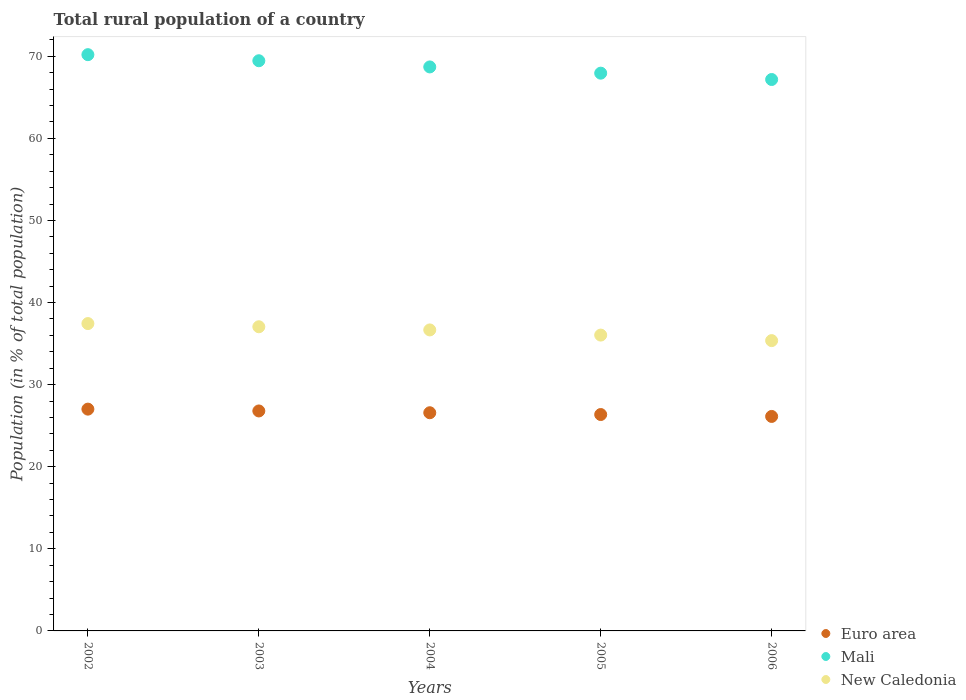Is the number of dotlines equal to the number of legend labels?
Provide a succinct answer. Yes. What is the rural population in New Caledonia in 2002?
Your response must be concise. 37.44. Across all years, what is the maximum rural population in New Caledonia?
Make the answer very short. 37.44. Across all years, what is the minimum rural population in Mali?
Your answer should be very brief. 67.17. What is the total rural population in Mali in the graph?
Offer a terse response. 343.45. What is the difference between the rural population in New Caledonia in 2003 and that in 2006?
Make the answer very short. 1.69. What is the difference between the rural population in Euro area in 2006 and the rural population in New Caledonia in 2004?
Keep it short and to the point. -10.54. What is the average rural population in New Caledonia per year?
Make the answer very short. 36.51. In the year 2005, what is the difference between the rural population in New Caledonia and rural population in Mali?
Your answer should be very brief. -31.91. What is the ratio of the rural population in New Caledonia in 2002 to that in 2004?
Your response must be concise. 1.02. Is the rural population in Mali in 2004 less than that in 2005?
Your answer should be compact. No. Is the difference between the rural population in New Caledonia in 2005 and 2006 greater than the difference between the rural population in Mali in 2005 and 2006?
Provide a succinct answer. No. What is the difference between the highest and the second highest rural population in Euro area?
Make the answer very short. 0.22. What is the difference between the highest and the lowest rural population in Mali?
Offer a terse response. 3.03. In how many years, is the rural population in Mali greater than the average rural population in Mali taken over all years?
Give a very brief answer. 3. Does the rural population in New Caledonia monotonically increase over the years?
Make the answer very short. No. Is the rural population in Mali strictly greater than the rural population in New Caledonia over the years?
Provide a succinct answer. Yes. Is the rural population in New Caledonia strictly less than the rural population in Mali over the years?
Offer a terse response. Yes. How many years are there in the graph?
Keep it short and to the point. 5. What is the difference between two consecutive major ticks on the Y-axis?
Keep it short and to the point. 10. Does the graph contain any zero values?
Give a very brief answer. No. Where does the legend appear in the graph?
Keep it short and to the point. Bottom right. What is the title of the graph?
Your answer should be compact. Total rural population of a country. What is the label or title of the Y-axis?
Give a very brief answer. Population (in % of total population). What is the Population (in % of total population) in Euro area in 2002?
Offer a terse response. 27.02. What is the Population (in % of total population) in Mali in 2002?
Ensure brevity in your answer.  70.19. What is the Population (in % of total population) of New Caledonia in 2002?
Provide a short and direct response. 37.44. What is the Population (in % of total population) of Euro area in 2003?
Your answer should be very brief. 26.79. What is the Population (in % of total population) in Mali in 2003?
Your response must be concise. 69.45. What is the Population (in % of total population) in New Caledonia in 2003?
Provide a succinct answer. 37.05. What is the Population (in % of total population) in Euro area in 2004?
Give a very brief answer. 26.58. What is the Population (in % of total population) of Mali in 2004?
Offer a very short reply. 68.7. What is the Population (in % of total population) in New Caledonia in 2004?
Your answer should be compact. 36.66. What is the Population (in % of total population) in Euro area in 2005?
Provide a succinct answer. 26.36. What is the Population (in % of total population) in Mali in 2005?
Provide a succinct answer. 67.94. What is the Population (in % of total population) in New Caledonia in 2005?
Ensure brevity in your answer.  36.03. What is the Population (in % of total population) of Euro area in 2006?
Your response must be concise. 26.13. What is the Population (in % of total population) in Mali in 2006?
Offer a very short reply. 67.17. What is the Population (in % of total population) in New Caledonia in 2006?
Your answer should be compact. 35.36. Across all years, what is the maximum Population (in % of total population) of Euro area?
Your response must be concise. 27.02. Across all years, what is the maximum Population (in % of total population) in Mali?
Provide a short and direct response. 70.19. Across all years, what is the maximum Population (in % of total population) in New Caledonia?
Offer a terse response. 37.44. Across all years, what is the minimum Population (in % of total population) in Euro area?
Keep it short and to the point. 26.13. Across all years, what is the minimum Population (in % of total population) in Mali?
Provide a succinct answer. 67.17. Across all years, what is the minimum Population (in % of total population) in New Caledonia?
Give a very brief answer. 35.36. What is the total Population (in % of total population) of Euro area in the graph?
Give a very brief answer. 132.87. What is the total Population (in % of total population) of Mali in the graph?
Provide a succinct answer. 343.45. What is the total Population (in % of total population) of New Caledonia in the graph?
Ensure brevity in your answer.  182.55. What is the difference between the Population (in % of total population) of Euro area in 2002 and that in 2003?
Make the answer very short. 0.22. What is the difference between the Population (in % of total population) in Mali in 2002 and that in 2003?
Give a very brief answer. 0.74. What is the difference between the Population (in % of total population) of New Caledonia in 2002 and that in 2003?
Your answer should be very brief. 0.39. What is the difference between the Population (in % of total population) in Euro area in 2002 and that in 2004?
Provide a succinct answer. 0.44. What is the difference between the Population (in % of total population) of Mali in 2002 and that in 2004?
Make the answer very short. 1.49. What is the difference between the Population (in % of total population) of New Caledonia in 2002 and that in 2004?
Offer a terse response. 0.78. What is the difference between the Population (in % of total population) in Euro area in 2002 and that in 2005?
Provide a short and direct response. 0.66. What is the difference between the Population (in % of total population) of Mali in 2002 and that in 2005?
Offer a very short reply. 2.25. What is the difference between the Population (in % of total population) in New Caledonia in 2002 and that in 2005?
Ensure brevity in your answer.  1.4. What is the difference between the Population (in % of total population) of Euro area in 2002 and that in 2006?
Offer a terse response. 0.89. What is the difference between the Population (in % of total population) in Mali in 2002 and that in 2006?
Make the answer very short. 3.03. What is the difference between the Population (in % of total population) in New Caledonia in 2002 and that in 2006?
Make the answer very short. 2.08. What is the difference between the Population (in % of total population) of Euro area in 2003 and that in 2004?
Provide a succinct answer. 0.22. What is the difference between the Population (in % of total population) in Mali in 2003 and that in 2004?
Your answer should be very brief. 0.75. What is the difference between the Population (in % of total population) of New Caledonia in 2003 and that in 2004?
Provide a succinct answer. 0.39. What is the difference between the Population (in % of total population) of Euro area in 2003 and that in 2005?
Provide a succinct answer. 0.44. What is the difference between the Population (in % of total population) of Mali in 2003 and that in 2005?
Make the answer very short. 1.51. What is the difference between the Population (in % of total population) of Euro area in 2003 and that in 2006?
Your answer should be very brief. 0.67. What is the difference between the Population (in % of total population) in Mali in 2003 and that in 2006?
Give a very brief answer. 2.29. What is the difference between the Population (in % of total population) of New Caledonia in 2003 and that in 2006?
Make the answer very short. 1.69. What is the difference between the Population (in % of total population) of Euro area in 2004 and that in 2005?
Your answer should be compact. 0.22. What is the difference between the Population (in % of total population) of Mali in 2004 and that in 2005?
Keep it short and to the point. 0.76. What is the difference between the Population (in % of total population) of New Caledonia in 2004 and that in 2005?
Provide a succinct answer. 0.63. What is the difference between the Population (in % of total population) of Euro area in 2004 and that in 2006?
Offer a very short reply. 0.45. What is the difference between the Population (in % of total population) of Mali in 2004 and that in 2006?
Provide a short and direct response. 1.53. What is the difference between the Population (in % of total population) in New Caledonia in 2004 and that in 2006?
Offer a very short reply. 1.3. What is the difference between the Population (in % of total population) in Euro area in 2005 and that in 2006?
Your answer should be very brief. 0.23. What is the difference between the Population (in % of total population) of Mali in 2005 and that in 2006?
Ensure brevity in your answer.  0.77. What is the difference between the Population (in % of total population) of New Caledonia in 2005 and that in 2006?
Provide a succinct answer. 0.67. What is the difference between the Population (in % of total population) of Euro area in 2002 and the Population (in % of total population) of Mali in 2003?
Your answer should be compact. -42.44. What is the difference between the Population (in % of total population) in Euro area in 2002 and the Population (in % of total population) in New Caledonia in 2003?
Your answer should be compact. -10.03. What is the difference between the Population (in % of total population) of Mali in 2002 and the Population (in % of total population) of New Caledonia in 2003?
Make the answer very short. 33.14. What is the difference between the Population (in % of total population) of Euro area in 2002 and the Population (in % of total population) of Mali in 2004?
Provide a short and direct response. -41.68. What is the difference between the Population (in % of total population) of Euro area in 2002 and the Population (in % of total population) of New Caledonia in 2004?
Give a very brief answer. -9.65. What is the difference between the Population (in % of total population) in Mali in 2002 and the Population (in % of total population) in New Caledonia in 2004?
Keep it short and to the point. 33.53. What is the difference between the Population (in % of total population) of Euro area in 2002 and the Population (in % of total population) of Mali in 2005?
Provide a succinct answer. -40.92. What is the difference between the Population (in % of total population) in Euro area in 2002 and the Population (in % of total population) in New Caledonia in 2005?
Keep it short and to the point. -9.02. What is the difference between the Population (in % of total population) of Mali in 2002 and the Population (in % of total population) of New Caledonia in 2005?
Offer a terse response. 34.16. What is the difference between the Population (in % of total population) of Euro area in 2002 and the Population (in % of total population) of Mali in 2006?
Offer a terse response. -40.15. What is the difference between the Population (in % of total population) in Euro area in 2002 and the Population (in % of total population) in New Caledonia in 2006?
Your response must be concise. -8.35. What is the difference between the Population (in % of total population) in Mali in 2002 and the Population (in % of total population) in New Caledonia in 2006?
Your answer should be very brief. 34.83. What is the difference between the Population (in % of total population) in Euro area in 2003 and the Population (in % of total population) in Mali in 2004?
Your answer should be very brief. -41.91. What is the difference between the Population (in % of total population) of Euro area in 2003 and the Population (in % of total population) of New Caledonia in 2004?
Offer a very short reply. -9.87. What is the difference between the Population (in % of total population) of Mali in 2003 and the Population (in % of total population) of New Caledonia in 2004?
Provide a succinct answer. 32.79. What is the difference between the Population (in % of total population) in Euro area in 2003 and the Population (in % of total population) in Mali in 2005?
Your answer should be very brief. -41.15. What is the difference between the Population (in % of total population) of Euro area in 2003 and the Population (in % of total population) of New Caledonia in 2005?
Offer a terse response. -9.24. What is the difference between the Population (in % of total population) in Mali in 2003 and the Population (in % of total population) in New Caledonia in 2005?
Your answer should be compact. 33.42. What is the difference between the Population (in % of total population) of Euro area in 2003 and the Population (in % of total population) of Mali in 2006?
Provide a succinct answer. -40.37. What is the difference between the Population (in % of total population) of Euro area in 2003 and the Population (in % of total population) of New Caledonia in 2006?
Your answer should be compact. -8.57. What is the difference between the Population (in % of total population) of Mali in 2003 and the Population (in % of total population) of New Caledonia in 2006?
Offer a very short reply. 34.09. What is the difference between the Population (in % of total population) of Euro area in 2004 and the Population (in % of total population) of Mali in 2005?
Make the answer very short. -41.36. What is the difference between the Population (in % of total population) in Euro area in 2004 and the Population (in % of total population) in New Caledonia in 2005?
Offer a terse response. -9.46. What is the difference between the Population (in % of total population) of Mali in 2004 and the Population (in % of total population) of New Caledonia in 2005?
Make the answer very short. 32.66. What is the difference between the Population (in % of total population) in Euro area in 2004 and the Population (in % of total population) in Mali in 2006?
Keep it short and to the point. -40.59. What is the difference between the Population (in % of total population) of Euro area in 2004 and the Population (in % of total population) of New Caledonia in 2006?
Your response must be concise. -8.79. What is the difference between the Population (in % of total population) of Mali in 2004 and the Population (in % of total population) of New Caledonia in 2006?
Your answer should be very brief. 33.34. What is the difference between the Population (in % of total population) of Euro area in 2005 and the Population (in % of total population) of Mali in 2006?
Provide a short and direct response. -40.81. What is the difference between the Population (in % of total population) in Euro area in 2005 and the Population (in % of total population) in New Caledonia in 2006?
Your answer should be compact. -9. What is the difference between the Population (in % of total population) of Mali in 2005 and the Population (in % of total population) of New Caledonia in 2006?
Provide a short and direct response. 32.58. What is the average Population (in % of total population) of Euro area per year?
Your answer should be very brief. 26.57. What is the average Population (in % of total population) of Mali per year?
Your answer should be compact. 68.69. What is the average Population (in % of total population) of New Caledonia per year?
Your response must be concise. 36.51. In the year 2002, what is the difference between the Population (in % of total population) in Euro area and Population (in % of total population) in Mali?
Your answer should be compact. -43.18. In the year 2002, what is the difference between the Population (in % of total population) of Euro area and Population (in % of total population) of New Caledonia?
Offer a terse response. -10.42. In the year 2002, what is the difference between the Population (in % of total population) of Mali and Population (in % of total population) of New Caledonia?
Give a very brief answer. 32.76. In the year 2003, what is the difference between the Population (in % of total population) in Euro area and Population (in % of total population) in Mali?
Your response must be concise. -42.66. In the year 2003, what is the difference between the Population (in % of total population) in Euro area and Population (in % of total population) in New Caledonia?
Make the answer very short. -10.26. In the year 2003, what is the difference between the Population (in % of total population) of Mali and Population (in % of total population) of New Caledonia?
Make the answer very short. 32.4. In the year 2004, what is the difference between the Population (in % of total population) of Euro area and Population (in % of total population) of Mali?
Your answer should be compact. -42.12. In the year 2004, what is the difference between the Population (in % of total population) of Euro area and Population (in % of total population) of New Caledonia?
Make the answer very short. -10.09. In the year 2004, what is the difference between the Population (in % of total population) of Mali and Population (in % of total population) of New Caledonia?
Your response must be concise. 32.04. In the year 2005, what is the difference between the Population (in % of total population) in Euro area and Population (in % of total population) in Mali?
Keep it short and to the point. -41.58. In the year 2005, what is the difference between the Population (in % of total population) of Euro area and Population (in % of total population) of New Caledonia?
Your answer should be compact. -9.68. In the year 2005, what is the difference between the Population (in % of total population) of Mali and Population (in % of total population) of New Caledonia?
Offer a very short reply. 31.91. In the year 2006, what is the difference between the Population (in % of total population) in Euro area and Population (in % of total population) in Mali?
Make the answer very short. -41.04. In the year 2006, what is the difference between the Population (in % of total population) in Euro area and Population (in % of total population) in New Caledonia?
Your answer should be very brief. -9.24. In the year 2006, what is the difference between the Population (in % of total population) of Mali and Population (in % of total population) of New Caledonia?
Provide a short and direct response. 31.81. What is the ratio of the Population (in % of total population) of Euro area in 2002 to that in 2003?
Your answer should be compact. 1.01. What is the ratio of the Population (in % of total population) of Mali in 2002 to that in 2003?
Make the answer very short. 1.01. What is the ratio of the Population (in % of total population) in New Caledonia in 2002 to that in 2003?
Provide a short and direct response. 1.01. What is the ratio of the Population (in % of total population) of Euro area in 2002 to that in 2004?
Keep it short and to the point. 1.02. What is the ratio of the Population (in % of total population) in Mali in 2002 to that in 2004?
Your response must be concise. 1.02. What is the ratio of the Population (in % of total population) in New Caledonia in 2002 to that in 2004?
Provide a succinct answer. 1.02. What is the ratio of the Population (in % of total population) in Mali in 2002 to that in 2005?
Give a very brief answer. 1.03. What is the ratio of the Population (in % of total population) of New Caledonia in 2002 to that in 2005?
Offer a terse response. 1.04. What is the ratio of the Population (in % of total population) of Euro area in 2002 to that in 2006?
Make the answer very short. 1.03. What is the ratio of the Population (in % of total population) of Mali in 2002 to that in 2006?
Provide a short and direct response. 1.05. What is the ratio of the Population (in % of total population) in New Caledonia in 2002 to that in 2006?
Provide a short and direct response. 1.06. What is the ratio of the Population (in % of total population) of Euro area in 2003 to that in 2004?
Give a very brief answer. 1.01. What is the ratio of the Population (in % of total population) of New Caledonia in 2003 to that in 2004?
Your answer should be very brief. 1.01. What is the ratio of the Population (in % of total population) of Euro area in 2003 to that in 2005?
Offer a very short reply. 1.02. What is the ratio of the Population (in % of total population) of Mali in 2003 to that in 2005?
Make the answer very short. 1.02. What is the ratio of the Population (in % of total population) of New Caledonia in 2003 to that in 2005?
Keep it short and to the point. 1.03. What is the ratio of the Population (in % of total population) in Euro area in 2003 to that in 2006?
Ensure brevity in your answer.  1.03. What is the ratio of the Population (in % of total population) in Mali in 2003 to that in 2006?
Provide a short and direct response. 1.03. What is the ratio of the Population (in % of total population) in New Caledonia in 2003 to that in 2006?
Provide a short and direct response. 1.05. What is the ratio of the Population (in % of total population) in Euro area in 2004 to that in 2005?
Provide a succinct answer. 1.01. What is the ratio of the Population (in % of total population) in Mali in 2004 to that in 2005?
Make the answer very short. 1.01. What is the ratio of the Population (in % of total population) in New Caledonia in 2004 to that in 2005?
Make the answer very short. 1.02. What is the ratio of the Population (in % of total population) of Euro area in 2004 to that in 2006?
Offer a very short reply. 1.02. What is the ratio of the Population (in % of total population) of Mali in 2004 to that in 2006?
Keep it short and to the point. 1.02. What is the ratio of the Population (in % of total population) of New Caledonia in 2004 to that in 2006?
Your answer should be compact. 1.04. What is the ratio of the Population (in % of total population) in Euro area in 2005 to that in 2006?
Your response must be concise. 1.01. What is the ratio of the Population (in % of total population) in Mali in 2005 to that in 2006?
Provide a succinct answer. 1.01. What is the ratio of the Population (in % of total population) in New Caledonia in 2005 to that in 2006?
Give a very brief answer. 1.02. What is the difference between the highest and the second highest Population (in % of total population) of Euro area?
Your response must be concise. 0.22. What is the difference between the highest and the second highest Population (in % of total population) of Mali?
Ensure brevity in your answer.  0.74. What is the difference between the highest and the second highest Population (in % of total population) of New Caledonia?
Provide a short and direct response. 0.39. What is the difference between the highest and the lowest Population (in % of total population) in Euro area?
Your response must be concise. 0.89. What is the difference between the highest and the lowest Population (in % of total population) of Mali?
Your answer should be very brief. 3.03. What is the difference between the highest and the lowest Population (in % of total population) of New Caledonia?
Make the answer very short. 2.08. 